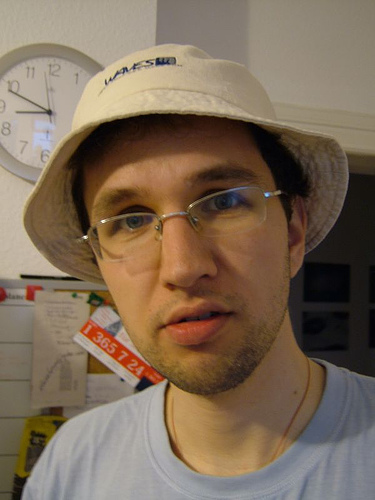Identify the text contained in this image. 12 11 10 8 7 365 WAVES 6 9 